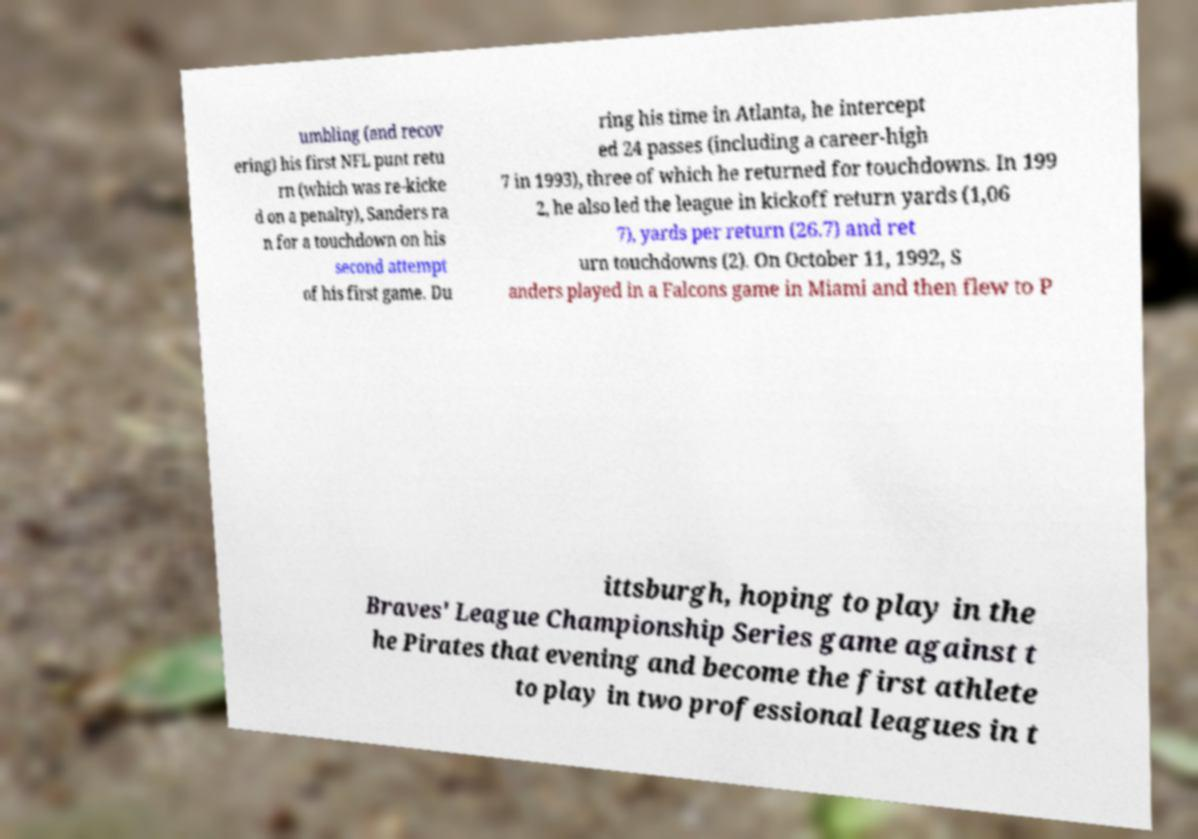For documentation purposes, I need the text within this image transcribed. Could you provide that? umbling (and recov ering) his first NFL punt retu rn (which was re-kicke d on a penalty), Sanders ra n for a touchdown on his second attempt of his first game. Du ring his time in Atlanta, he intercept ed 24 passes (including a career-high 7 in 1993), three of which he returned for touchdowns. In 199 2, he also led the league in kickoff return yards (1,06 7), yards per return (26.7) and ret urn touchdowns (2). On October 11, 1992, S anders played in a Falcons game in Miami and then flew to P ittsburgh, hoping to play in the Braves' League Championship Series game against t he Pirates that evening and become the first athlete to play in two professional leagues in t 